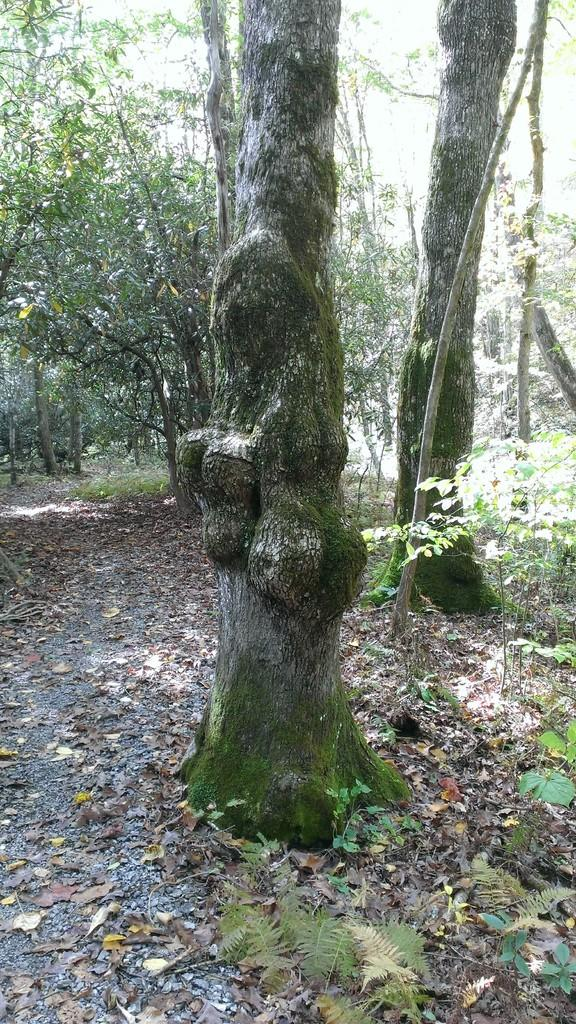What type of vegetation can be seen in the image? There are trees in the image. What part of the trees can be seen at the bottom of the image? There are leaves at the bottom of the image. Can you see any airplanes flying over the trees in the image? There is no mention of an airplane in the image, so it cannot be determined if one is present. 